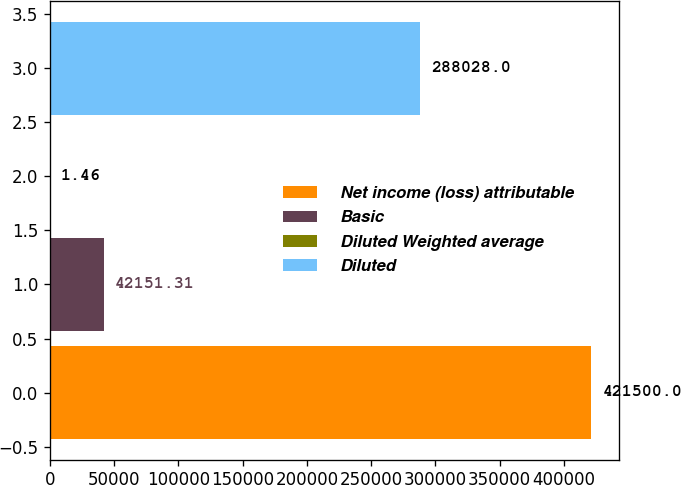Convert chart. <chart><loc_0><loc_0><loc_500><loc_500><bar_chart><fcel>Net income (loss) attributable<fcel>Basic<fcel>Diluted Weighted average<fcel>Diluted<nl><fcel>421500<fcel>42151.3<fcel>1.46<fcel>288028<nl></chart> 